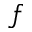Convert formula to latex. <formula><loc_0><loc_0><loc_500><loc_500>f</formula> 